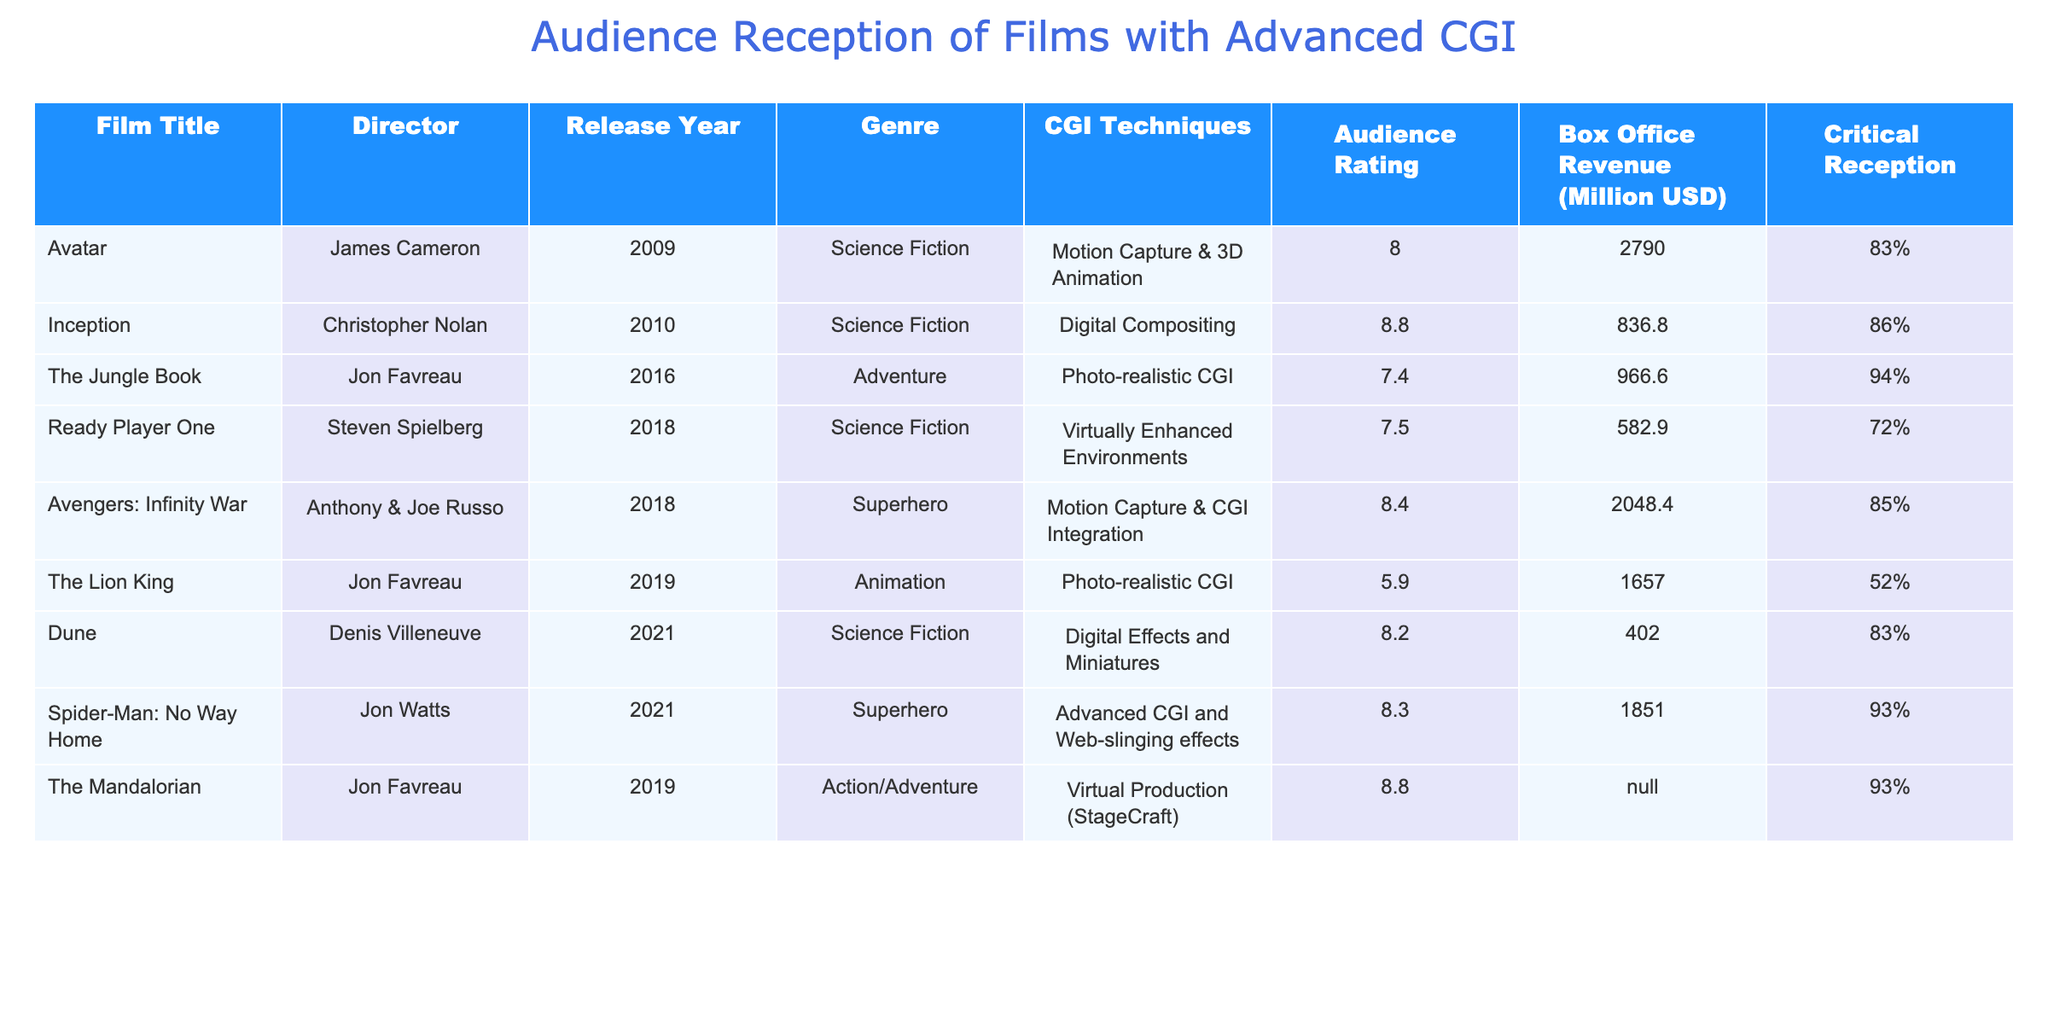What is the audience rating for "Avatar"? The table has the audience rating displayed next to the film title "Avatar". It shows an audience rating of 8.0.
Answer: 8.0 Which film had the highest box office revenue? By scanning the box office revenue column, the highest value is associated with "Avatar", which has a box office revenue of 2790.0 million USD.
Answer: Avatar What genre does "Ready Player One" belong to? The genre of "Ready Player One" is listed in the table next to the film title, which shows it as a Science Fiction film.
Answer: Science Fiction How many films have an audience rating above 8.0? Checking the audience ratings, the films "Inception", "Avengers: Infinity War", "Spider-Man: No Way Home", and "The Mandalorian" all have ratings above 8.0. There are four films in total.
Answer: 4 What is the average audience rating of films directed by Jon Favreau? The ratings for the films directed by Jon Favreau are 7.4 (The Jungle Book), 5.9 (The Lion King), and 8.8 (The Mandalorian). To find the average, sum these ratings: 7.4 + 5.9 + 8.8 = 22.1. Since there are 3 films: 22.1 / 3 = 7.3667, approximately 7.4.
Answer: 7.4 Did "The Lion King" perform well at the box office compared to "Spider-Man: No Way Home"? "The Lion King" has a box office revenue of 1657.0 million USD, while "Spider-Man: No Way Home" has 1851.0 million USD. Since 1657.0 is less than 1851.0, "The Lion King" did not perform as well.
Answer: No Which film features "Virtual Production (StageCraft)" as a CGI technique? The table specifies that "The Mandalorian" uses "Virtual Production (StageCraft)" as its CGI technique, as listed in the corresponding column.
Answer: The Mandalorian What is the difference in audience ratings between "Inception" and "The Lion King"? "Inception" has an audience rating of 8.8, while "The Lion King" has a rating of 5.9. The difference can be calculated as 8.8 - 5.9 = 2.9.
Answer: 2.9 Which director's films consistently achieved an audience rating of at least 8.0? Looking at the audience ratings, films directed by James Cameron, Christopher Nolan, and Jon Watts have ratings of at least 8.0. Other directors like Jon Favreau have some films below 8.0.
Answer: James Cameron, Christopher Nolan, Jon Watts How does "Dune" compare to "Ready Player One" in terms of critical reception? "Dune" has a critical reception of 83%, while "Ready Player One" has a lower reception of 72%. Therefore, "Dune" has a better critical reception than "Ready Player One".
Answer: Dune has a better critical reception 